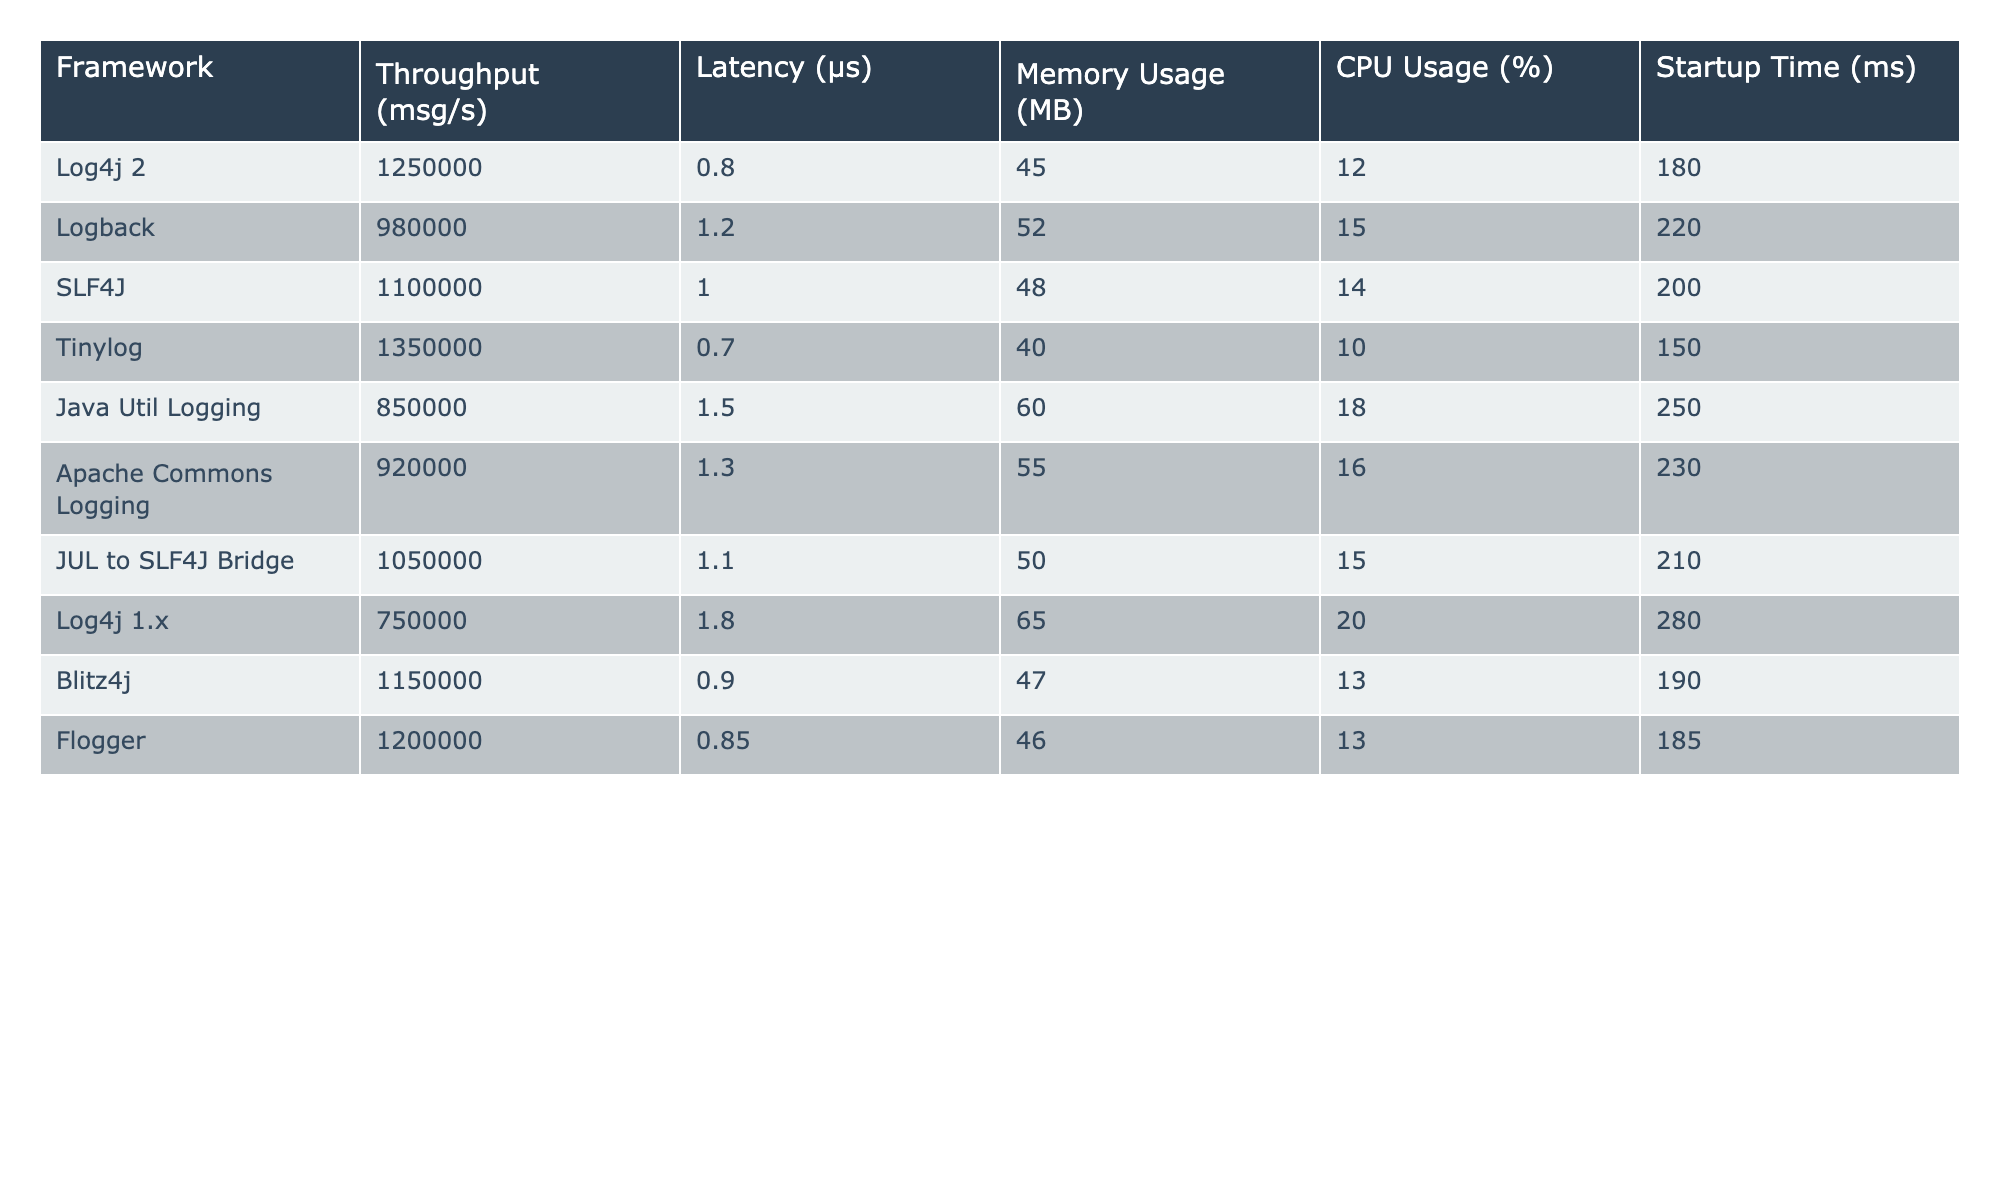What is the throughput of Logback? From the table, in the row corresponding to Logback, the throughput is listed under the Throughput (msg/s) column which shows 980000.
Answer: 980000 Which framework has the highest CPU usage? By examining the CPU Usage (%) column, Log4j 1.x has the highest value at 20%.
Answer: 20% What is the average latency of all frameworks listed? To find the average latency, sum all the latency values: (0.8 + 1.2 + 1.0 + 0.7 + 1.5 + 1.3 + 1.1 + 1.8 + 0.9 + 0.85) = 10.5 µs. There are 10 frameworks, so the average latency is 10.5/10 = 1.05 µs.
Answer: 1.05 µs Is the memory usage of SLF4J greater than that of Tinylog? SLF4J shows a memory usage of 48 MB and Tinylog shows 40 MB. Since 48 MB > 40 MB, the statement is true.
Answer: Yes Identify which framework has the least startup time? Looking at the Startup Time (ms) column, Tinylog has the least value at 150 ms, which is lower than all other frameworks.
Answer: Tinylog What is the difference in throughput between the best and worst performing frameworks? The best performing framework is Log4j 2 with a throughput of 1250000, and the worst is Log4j 1.x with 750000. The difference is 1250000 - 750000 = 500000 msg/s.
Answer: 500000 msg/s Does Flogger have higher throughput than Java Util Logging? Flogger has a throughput of 1200000 and Java Util Logging has 850000. Since 1200000 is greater than 850000, the statement is true.
Answer: Yes Which framework has the highest memory usage? Scanning through the Memory Usage (MB) column, Java Util Logging shows the highest value at 60 MB, which is higher than all other frameworks.
Answer: Java Util Logging What is the median CPU usage of the frameworks? The CPU Usage values are: 12, 15, 14, 10, 18, 16, 15, 20, 13, and 13. When sorted, the values are: 10, 12, 13, 13, 14, 15, 15, 16, 18, 20. The median (average of 14 and 15) is (14 + 15)/2 = 14.5%.
Answer: 14.5% 